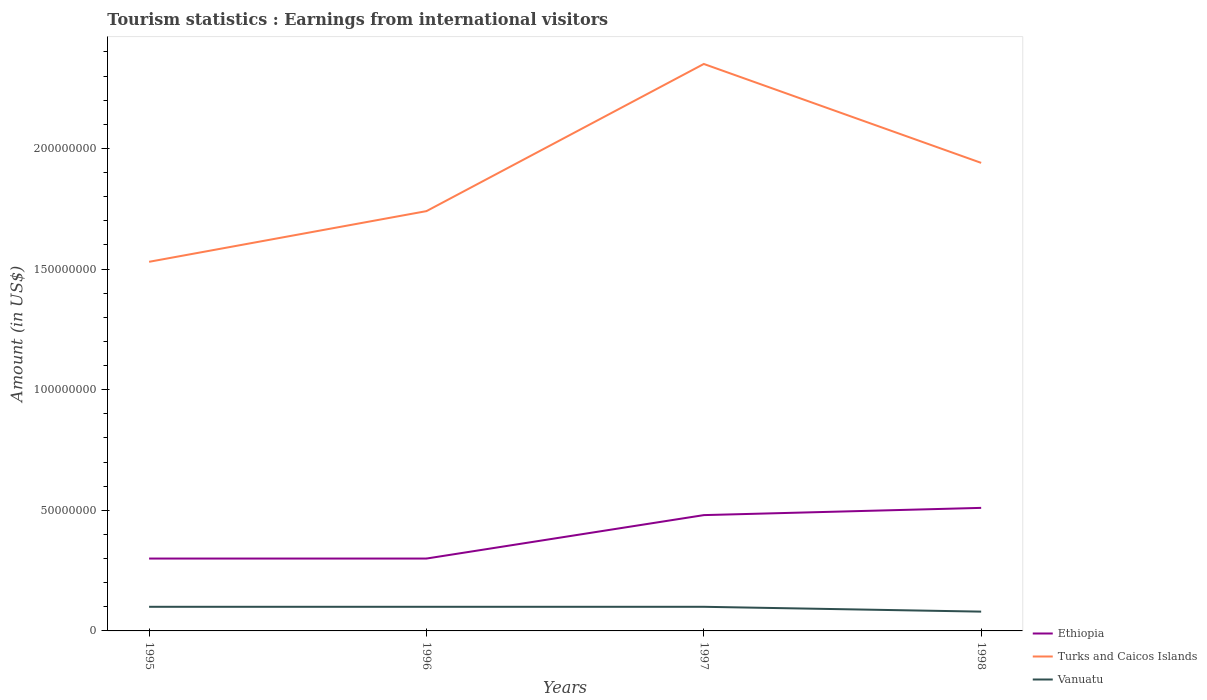How many different coloured lines are there?
Provide a short and direct response. 3. Does the line corresponding to Ethiopia intersect with the line corresponding to Vanuatu?
Your response must be concise. No. Is the number of lines equal to the number of legend labels?
Your answer should be compact. Yes. Across all years, what is the maximum earnings from international visitors in Turks and Caicos Islands?
Your answer should be very brief. 1.53e+08. What is the total earnings from international visitors in Turks and Caicos Islands in the graph?
Your answer should be compact. -6.10e+07. What is the difference between the highest and the second highest earnings from international visitors in Ethiopia?
Provide a short and direct response. 2.10e+07. Is the earnings from international visitors in Ethiopia strictly greater than the earnings from international visitors in Turks and Caicos Islands over the years?
Provide a succinct answer. Yes. How many lines are there?
Offer a very short reply. 3. How many years are there in the graph?
Make the answer very short. 4. Does the graph contain any zero values?
Give a very brief answer. No. Does the graph contain grids?
Ensure brevity in your answer.  No. Where does the legend appear in the graph?
Offer a terse response. Bottom right. What is the title of the graph?
Make the answer very short. Tourism statistics : Earnings from international visitors. Does "Hungary" appear as one of the legend labels in the graph?
Make the answer very short. No. What is the label or title of the X-axis?
Your answer should be very brief. Years. What is the Amount (in US$) in Ethiopia in 1995?
Make the answer very short. 3.00e+07. What is the Amount (in US$) of Turks and Caicos Islands in 1995?
Provide a succinct answer. 1.53e+08. What is the Amount (in US$) of Vanuatu in 1995?
Offer a very short reply. 1.00e+07. What is the Amount (in US$) in Ethiopia in 1996?
Make the answer very short. 3.00e+07. What is the Amount (in US$) in Turks and Caicos Islands in 1996?
Offer a very short reply. 1.74e+08. What is the Amount (in US$) of Vanuatu in 1996?
Your answer should be very brief. 1.00e+07. What is the Amount (in US$) in Ethiopia in 1997?
Make the answer very short. 4.80e+07. What is the Amount (in US$) in Turks and Caicos Islands in 1997?
Keep it short and to the point. 2.35e+08. What is the Amount (in US$) of Vanuatu in 1997?
Provide a succinct answer. 1.00e+07. What is the Amount (in US$) in Ethiopia in 1998?
Offer a terse response. 5.10e+07. What is the Amount (in US$) of Turks and Caicos Islands in 1998?
Make the answer very short. 1.94e+08. Across all years, what is the maximum Amount (in US$) in Ethiopia?
Your response must be concise. 5.10e+07. Across all years, what is the maximum Amount (in US$) of Turks and Caicos Islands?
Provide a succinct answer. 2.35e+08. Across all years, what is the maximum Amount (in US$) of Vanuatu?
Provide a short and direct response. 1.00e+07. Across all years, what is the minimum Amount (in US$) of Ethiopia?
Provide a short and direct response. 3.00e+07. Across all years, what is the minimum Amount (in US$) of Turks and Caicos Islands?
Your answer should be very brief. 1.53e+08. Across all years, what is the minimum Amount (in US$) of Vanuatu?
Make the answer very short. 8.00e+06. What is the total Amount (in US$) in Ethiopia in the graph?
Give a very brief answer. 1.59e+08. What is the total Amount (in US$) in Turks and Caicos Islands in the graph?
Your answer should be compact. 7.56e+08. What is the total Amount (in US$) of Vanuatu in the graph?
Offer a terse response. 3.80e+07. What is the difference between the Amount (in US$) in Turks and Caicos Islands in 1995 and that in 1996?
Your response must be concise. -2.10e+07. What is the difference between the Amount (in US$) of Ethiopia in 1995 and that in 1997?
Offer a terse response. -1.80e+07. What is the difference between the Amount (in US$) in Turks and Caicos Islands in 1995 and that in 1997?
Give a very brief answer. -8.20e+07. What is the difference between the Amount (in US$) in Ethiopia in 1995 and that in 1998?
Offer a terse response. -2.10e+07. What is the difference between the Amount (in US$) of Turks and Caicos Islands in 1995 and that in 1998?
Provide a short and direct response. -4.10e+07. What is the difference between the Amount (in US$) in Vanuatu in 1995 and that in 1998?
Your response must be concise. 2.00e+06. What is the difference between the Amount (in US$) of Ethiopia in 1996 and that in 1997?
Offer a terse response. -1.80e+07. What is the difference between the Amount (in US$) in Turks and Caicos Islands in 1996 and that in 1997?
Your answer should be compact. -6.10e+07. What is the difference between the Amount (in US$) in Ethiopia in 1996 and that in 1998?
Make the answer very short. -2.10e+07. What is the difference between the Amount (in US$) in Turks and Caicos Islands in 1996 and that in 1998?
Offer a very short reply. -2.00e+07. What is the difference between the Amount (in US$) in Vanuatu in 1996 and that in 1998?
Offer a very short reply. 2.00e+06. What is the difference between the Amount (in US$) in Ethiopia in 1997 and that in 1998?
Offer a very short reply. -3.00e+06. What is the difference between the Amount (in US$) in Turks and Caicos Islands in 1997 and that in 1998?
Your answer should be compact. 4.10e+07. What is the difference between the Amount (in US$) of Ethiopia in 1995 and the Amount (in US$) of Turks and Caicos Islands in 1996?
Provide a short and direct response. -1.44e+08. What is the difference between the Amount (in US$) of Ethiopia in 1995 and the Amount (in US$) of Vanuatu in 1996?
Ensure brevity in your answer.  2.00e+07. What is the difference between the Amount (in US$) in Turks and Caicos Islands in 1995 and the Amount (in US$) in Vanuatu in 1996?
Provide a succinct answer. 1.43e+08. What is the difference between the Amount (in US$) of Ethiopia in 1995 and the Amount (in US$) of Turks and Caicos Islands in 1997?
Your answer should be compact. -2.05e+08. What is the difference between the Amount (in US$) in Turks and Caicos Islands in 1995 and the Amount (in US$) in Vanuatu in 1997?
Make the answer very short. 1.43e+08. What is the difference between the Amount (in US$) in Ethiopia in 1995 and the Amount (in US$) in Turks and Caicos Islands in 1998?
Your response must be concise. -1.64e+08. What is the difference between the Amount (in US$) of Ethiopia in 1995 and the Amount (in US$) of Vanuatu in 1998?
Keep it short and to the point. 2.20e+07. What is the difference between the Amount (in US$) in Turks and Caicos Islands in 1995 and the Amount (in US$) in Vanuatu in 1998?
Your answer should be very brief. 1.45e+08. What is the difference between the Amount (in US$) in Ethiopia in 1996 and the Amount (in US$) in Turks and Caicos Islands in 1997?
Give a very brief answer. -2.05e+08. What is the difference between the Amount (in US$) of Turks and Caicos Islands in 1996 and the Amount (in US$) of Vanuatu in 1997?
Your response must be concise. 1.64e+08. What is the difference between the Amount (in US$) in Ethiopia in 1996 and the Amount (in US$) in Turks and Caicos Islands in 1998?
Offer a very short reply. -1.64e+08. What is the difference between the Amount (in US$) in Ethiopia in 1996 and the Amount (in US$) in Vanuatu in 1998?
Keep it short and to the point. 2.20e+07. What is the difference between the Amount (in US$) in Turks and Caicos Islands in 1996 and the Amount (in US$) in Vanuatu in 1998?
Keep it short and to the point. 1.66e+08. What is the difference between the Amount (in US$) in Ethiopia in 1997 and the Amount (in US$) in Turks and Caicos Islands in 1998?
Ensure brevity in your answer.  -1.46e+08. What is the difference between the Amount (in US$) of Ethiopia in 1997 and the Amount (in US$) of Vanuatu in 1998?
Keep it short and to the point. 4.00e+07. What is the difference between the Amount (in US$) in Turks and Caicos Islands in 1997 and the Amount (in US$) in Vanuatu in 1998?
Make the answer very short. 2.27e+08. What is the average Amount (in US$) in Ethiopia per year?
Ensure brevity in your answer.  3.98e+07. What is the average Amount (in US$) in Turks and Caicos Islands per year?
Make the answer very short. 1.89e+08. What is the average Amount (in US$) in Vanuatu per year?
Ensure brevity in your answer.  9.50e+06. In the year 1995, what is the difference between the Amount (in US$) of Ethiopia and Amount (in US$) of Turks and Caicos Islands?
Give a very brief answer. -1.23e+08. In the year 1995, what is the difference between the Amount (in US$) of Ethiopia and Amount (in US$) of Vanuatu?
Make the answer very short. 2.00e+07. In the year 1995, what is the difference between the Amount (in US$) of Turks and Caicos Islands and Amount (in US$) of Vanuatu?
Ensure brevity in your answer.  1.43e+08. In the year 1996, what is the difference between the Amount (in US$) of Ethiopia and Amount (in US$) of Turks and Caicos Islands?
Ensure brevity in your answer.  -1.44e+08. In the year 1996, what is the difference between the Amount (in US$) of Ethiopia and Amount (in US$) of Vanuatu?
Offer a very short reply. 2.00e+07. In the year 1996, what is the difference between the Amount (in US$) in Turks and Caicos Islands and Amount (in US$) in Vanuatu?
Provide a short and direct response. 1.64e+08. In the year 1997, what is the difference between the Amount (in US$) in Ethiopia and Amount (in US$) in Turks and Caicos Islands?
Offer a very short reply. -1.87e+08. In the year 1997, what is the difference between the Amount (in US$) in Ethiopia and Amount (in US$) in Vanuatu?
Your answer should be very brief. 3.80e+07. In the year 1997, what is the difference between the Amount (in US$) of Turks and Caicos Islands and Amount (in US$) of Vanuatu?
Your response must be concise. 2.25e+08. In the year 1998, what is the difference between the Amount (in US$) of Ethiopia and Amount (in US$) of Turks and Caicos Islands?
Keep it short and to the point. -1.43e+08. In the year 1998, what is the difference between the Amount (in US$) of Ethiopia and Amount (in US$) of Vanuatu?
Your answer should be compact. 4.30e+07. In the year 1998, what is the difference between the Amount (in US$) in Turks and Caicos Islands and Amount (in US$) in Vanuatu?
Your answer should be very brief. 1.86e+08. What is the ratio of the Amount (in US$) in Ethiopia in 1995 to that in 1996?
Your answer should be compact. 1. What is the ratio of the Amount (in US$) of Turks and Caicos Islands in 1995 to that in 1996?
Make the answer very short. 0.88. What is the ratio of the Amount (in US$) in Vanuatu in 1995 to that in 1996?
Your answer should be very brief. 1. What is the ratio of the Amount (in US$) in Turks and Caicos Islands in 1995 to that in 1997?
Provide a short and direct response. 0.65. What is the ratio of the Amount (in US$) of Vanuatu in 1995 to that in 1997?
Ensure brevity in your answer.  1. What is the ratio of the Amount (in US$) of Ethiopia in 1995 to that in 1998?
Offer a very short reply. 0.59. What is the ratio of the Amount (in US$) of Turks and Caicos Islands in 1995 to that in 1998?
Offer a terse response. 0.79. What is the ratio of the Amount (in US$) of Turks and Caicos Islands in 1996 to that in 1997?
Make the answer very short. 0.74. What is the ratio of the Amount (in US$) in Ethiopia in 1996 to that in 1998?
Keep it short and to the point. 0.59. What is the ratio of the Amount (in US$) in Turks and Caicos Islands in 1996 to that in 1998?
Your answer should be compact. 0.9. What is the ratio of the Amount (in US$) in Ethiopia in 1997 to that in 1998?
Your answer should be compact. 0.94. What is the ratio of the Amount (in US$) in Turks and Caicos Islands in 1997 to that in 1998?
Your answer should be very brief. 1.21. What is the ratio of the Amount (in US$) in Vanuatu in 1997 to that in 1998?
Offer a terse response. 1.25. What is the difference between the highest and the second highest Amount (in US$) in Ethiopia?
Make the answer very short. 3.00e+06. What is the difference between the highest and the second highest Amount (in US$) of Turks and Caicos Islands?
Make the answer very short. 4.10e+07. What is the difference between the highest and the second highest Amount (in US$) in Vanuatu?
Your answer should be compact. 0. What is the difference between the highest and the lowest Amount (in US$) in Ethiopia?
Your answer should be very brief. 2.10e+07. What is the difference between the highest and the lowest Amount (in US$) in Turks and Caicos Islands?
Your answer should be compact. 8.20e+07. 